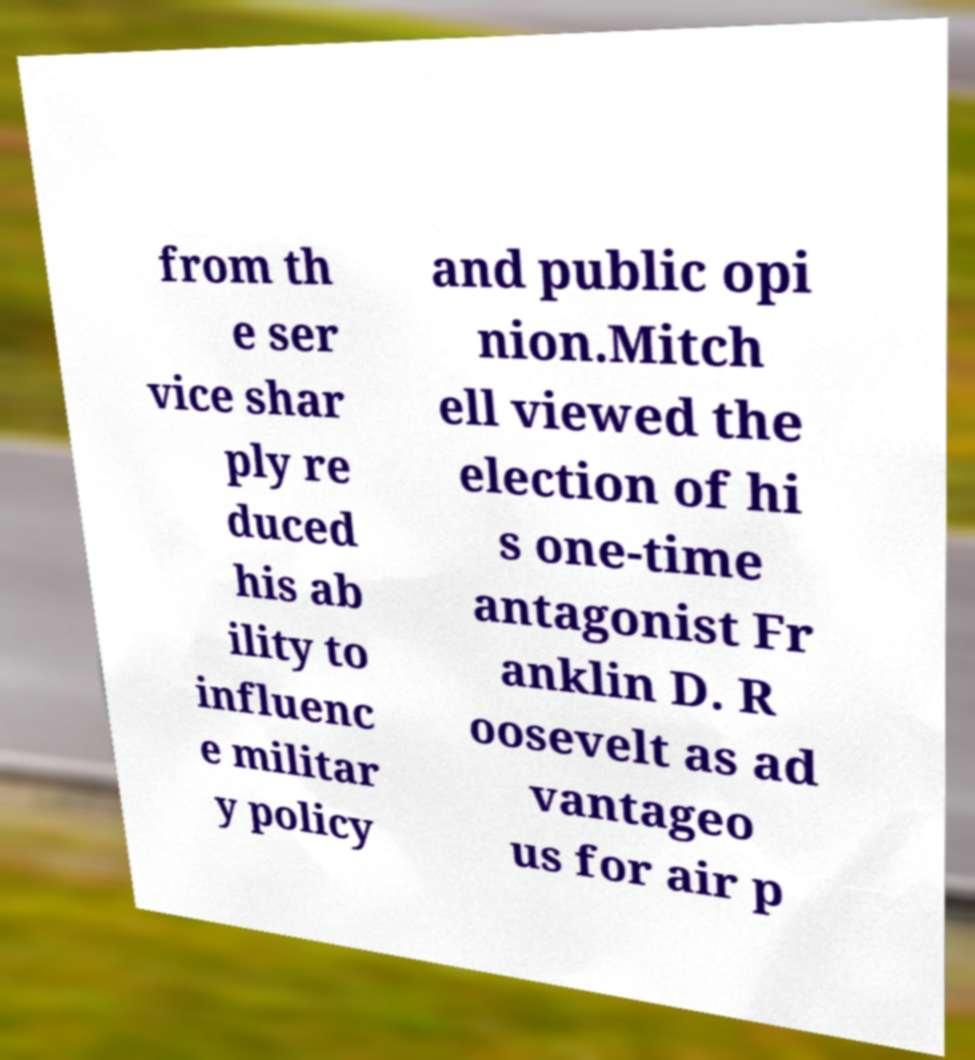What messages or text are displayed in this image? I need them in a readable, typed format. from th e ser vice shar ply re duced his ab ility to influenc e militar y policy and public opi nion.Mitch ell viewed the election of hi s one-time antagonist Fr anklin D. R oosevelt as ad vantageo us for air p 